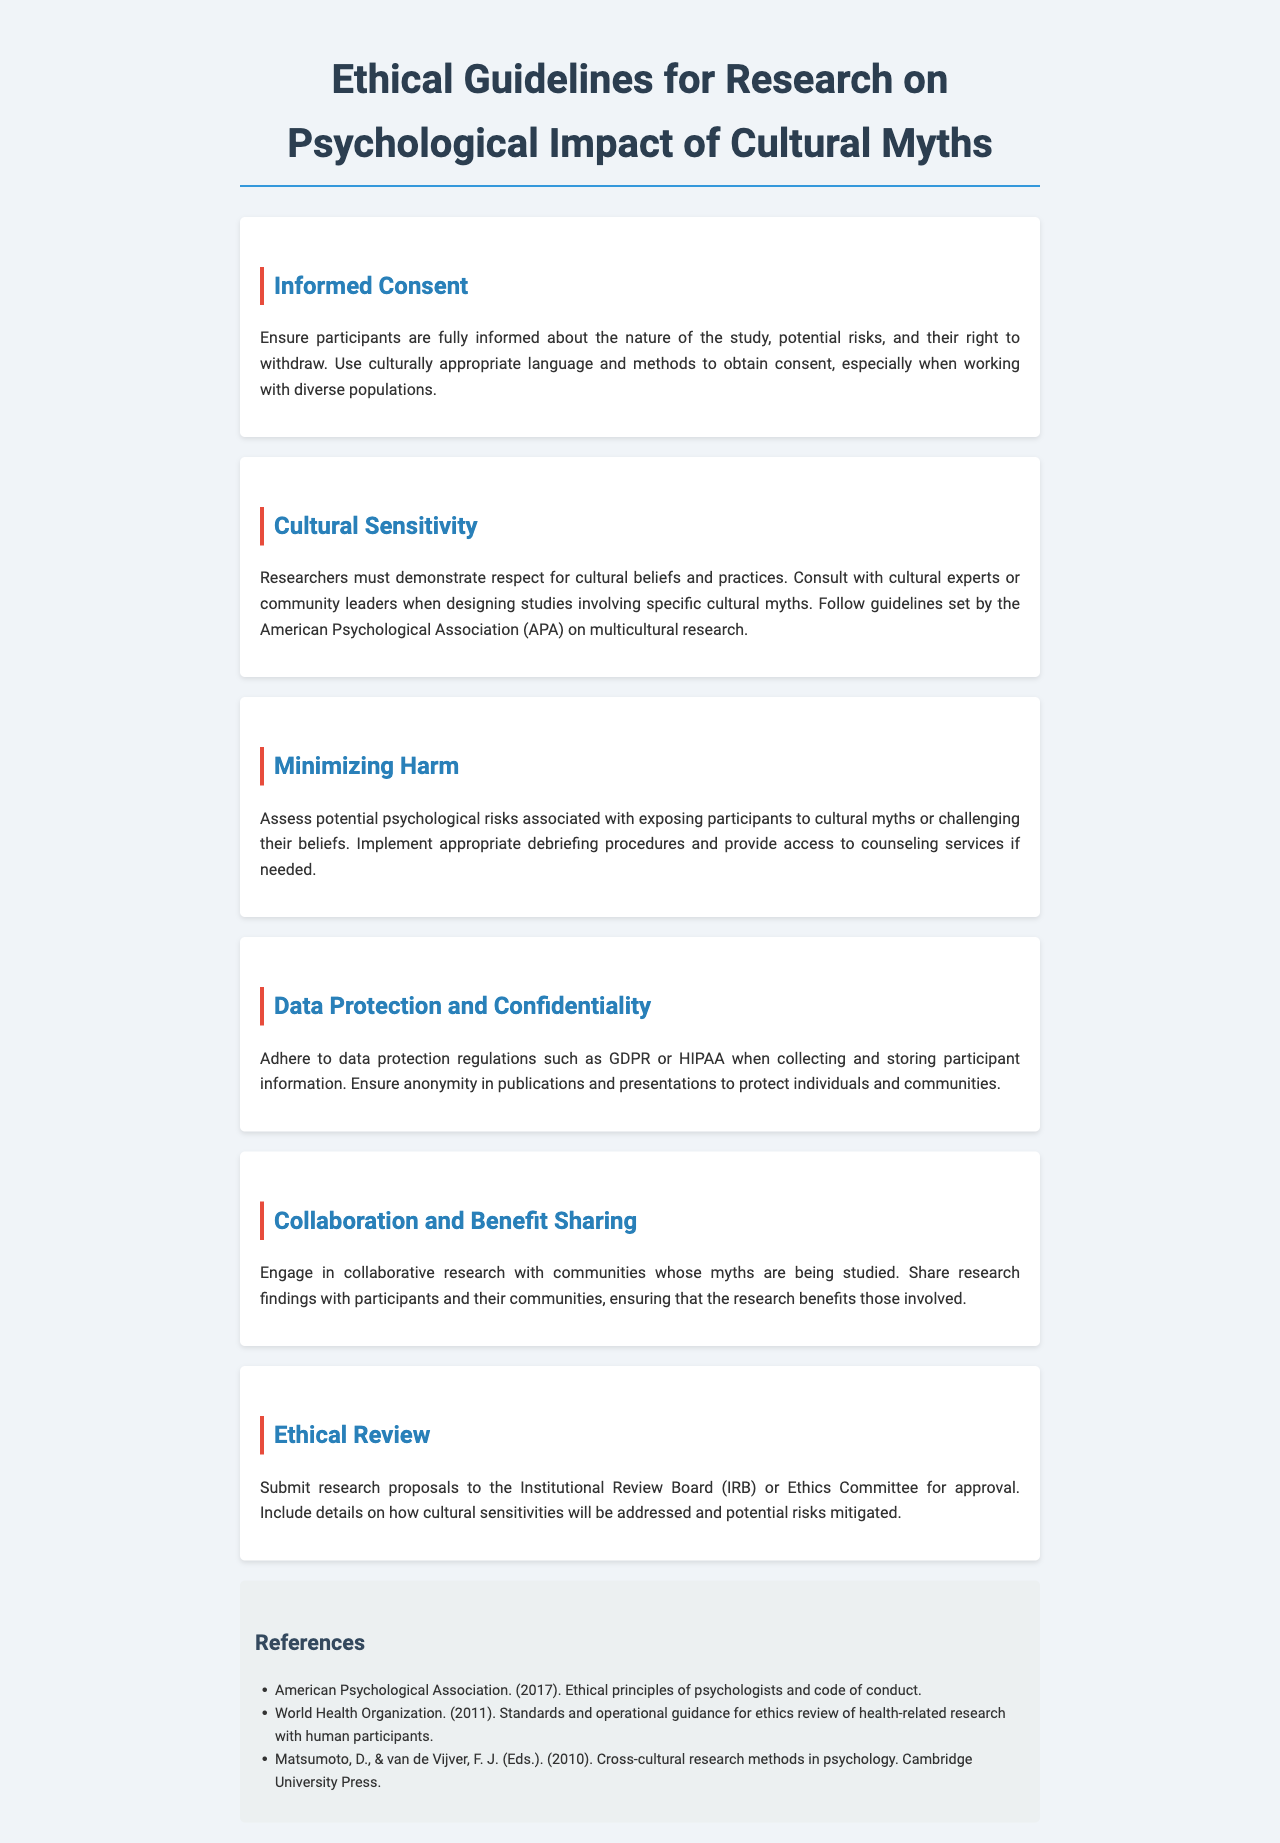What is the title of the document? The title of the document is explicitly stated at the top of the rendered page.
Answer: Ethical Guidelines for Research on Psychological Impact of Cultural Myths What is required from participants before the study? The document states the importance of informed consent which is necessary before conducting the study.
Answer: Informed consent Which organization's guidelines should researchers follow regarding multicultural research? The document suggests following specific guidelines set by a recognized national organization in psychology regarding multicultural research.
Answer: American Psychological Association What psychological risks should researchers assess? The document highlights the importance of assessing potential psychological risks associated with exposing participants to cultural myths.
Answer: Potential psychological risks What should be submitted for research proposals? The document mentions that research proposals need to be submitted for ethical review to a specific board.
Answer: Institutional Review Board How should researchers protect participant information? The document outlines certain regulations that must be adhered to in order to protect participant information.
Answer: GDPR or HIPAA What can researchers provide after assessing harm? The guidelines highlight that appropriate support should be available following potential psychological challenges in a study.
Answer: Counseling services Why is collaboration with communities emphasized? The document states that engaging with communities being studied ensures research benefits and respect for their narratives.
Answer: Benefit sharing What specific cultural aspect must researchers demonstrate? The document emphasizes the need for researchers to respect certain elements in their studies concerning myths.
Answer: Cultural beliefs and practices 